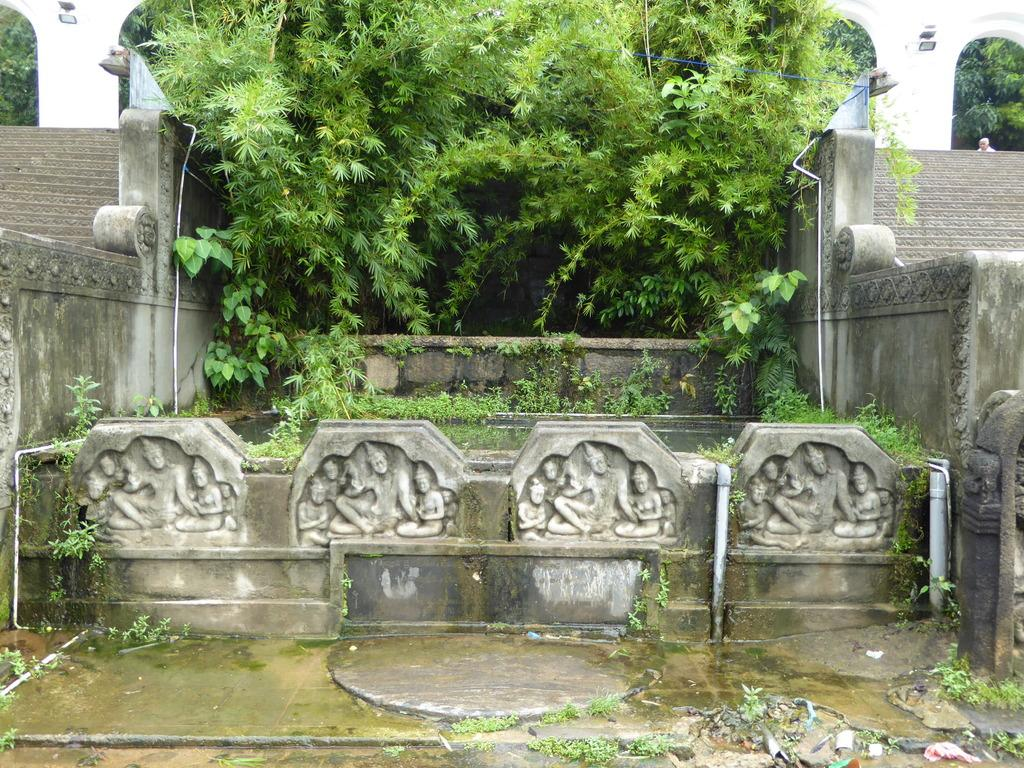What can be seen on the wall in the image? There are statues on the wall in the image. What type of natural elements are present in the image? There are trees and plants in the image. Are there any architectural features visible in the image? Yes, there are steps in the image. Can you describe the background of the image? In the background, there is a person visible, and there are pillars present. What type of sweater is the lawyer wearing in the image? There is no lawyer or sweater present in the image. What is the person's belief system in the image? The provided facts do not mention or imply any belief system for the person visible in the background. 